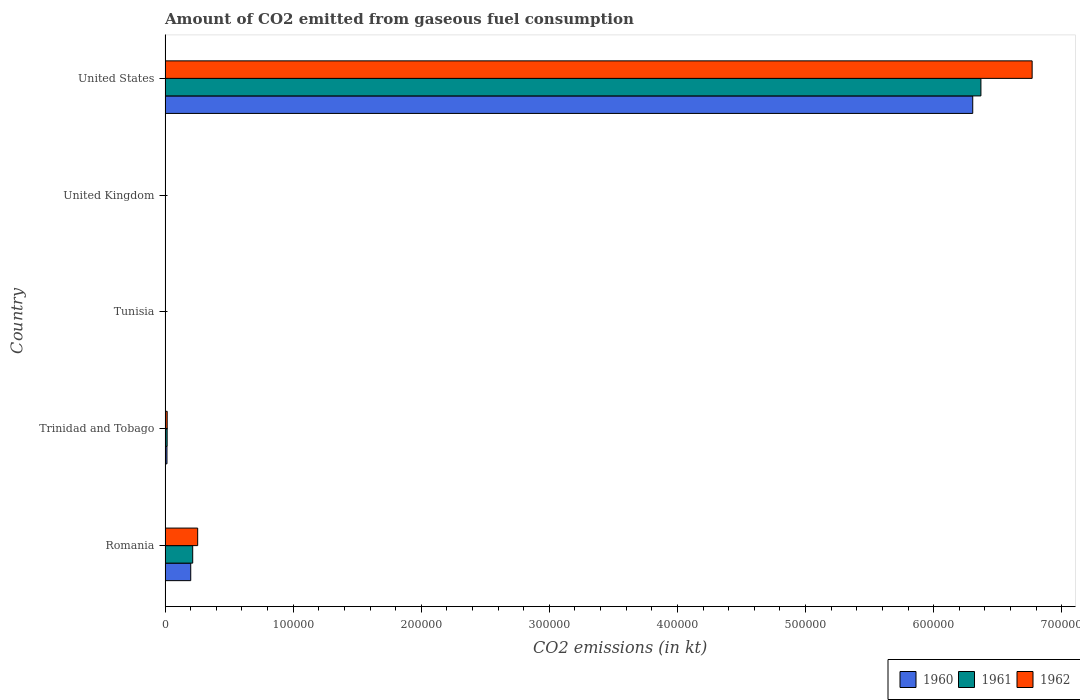How many different coloured bars are there?
Give a very brief answer. 3. Are the number of bars per tick equal to the number of legend labels?
Offer a very short reply. Yes. How many bars are there on the 5th tick from the top?
Your answer should be very brief. 3. What is the label of the 4th group of bars from the top?
Your answer should be very brief. Trinidad and Tobago. What is the amount of CO2 emitted in 1961 in Tunisia?
Make the answer very short. 14.67. Across all countries, what is the maximum amount of CO2 emitted in 1960?
Offer a very short reply. 6.31e+05. Across all countries, what is the minimum amount of CO2 emitted in 1962?
Offer a very short reply. 14.67. In which country was the amount of CO2 emitted in 1960 minimum?
Ensure brevity in your answer.  Tunisia. What is the total amount of CO2 emitted in 1961 in the graph?
Give a very brief answer. 6.60e+05. What is the difference between the amount of CO2 emitted in 1961 in Tunisia and that in United Kingdom?
Make the answer very short. -135.68. What is the difference between the amount of CO2 emitted in 1962 in Tunisia and the amount of CO2 emitted in 1961 in Trinidad and Tobago?
Provide a short and direct response. -1580.48. What is the average amount of CO2 emitted in 1962 per country?
Your response must be concise. 1.41e+05. What is the difference between the amount of CO2 emitted in 1961 and amount of CO2 emitted in 1962 in Trinidad and Tobago?
Offer a very short reply. -33. In how many countries, is the amount of CO2 emitted in 1962 greater than 140000 kt?
Your answer should be compact. 1. What is the ratio of the amount of CO2 emitted in 1960 in Romania to that in Tunisia?
Give a very brief answer. 1364.75. Is the amount of CO2 emitted in 1962 in Romania less than that in Tunisia?
Give a very brief answer. No. Is the difference between the amount of CO2 emitted in 1961 in Tunisia and United Kingdom greater than the difference between the amount of CO2 emitted in 1962 in Tunisia and United Kingdom?
Offer a terse response. Yes. What is the difference between the highest and the second highest amount of CO2 emitted in 1961?
Offer a terse response. 6.15e+05. What is the difference between the highest and the lowest amount of CO2 emitted in 1962?
Offer a terse response. 6.77e+05. Does the graph contain any zero values?
Give a very brief answer. No. Does the graph contain grids?
Make the answer very short. No. How many legend labels are there?
Keep it short and to the point. 3. How are the legend labels stacked?
Make the answer very short. Horizontal. What is the title of the graph?
Ensure brevity in your answer.  Amount of CO2 emitted from gaseous fuel consumption. What is the label or title of the X-axis?
Give a very brief answer. CO2 emissions (in kt). What is the CO2 emissions (in kt) of 1960 in Romania?
Offer a very short reply. 2.00e+04. What is the CO2 emissions (in kt) in 1961 in Romania?
Provide a succinct answer. 2.16e+04. What is the CO2 emissions (in kt) of 1962 in Romania?
Offer a terse response. 2.54e+04. What is the CO2 emissions (in kt) of 1960 in Trinidad and Tobago?
Your answer should be compact. 1466.8. What is the CO2 emissions (in kt) in 1961 in Trinidad and Tobago?
Provide a short and direct response. 1595.14. What is the CO2 emissions (in kt) in 1962 in Trinidad and Tobago?
Give a very brief answer. 1628.15. What is the CO2 emissions (in kt) of 1960 in Tunisia?
Make the answer very short. 14.67. What is the CO2 emissions (in kt) of 1961 in Tunisia?
Make the answer very short. 14.67. What is the CO2 emissions (in kt) of 1962 in Tunisia?
Make the answer very short. 14.67. What is the CO2 emissions (in kt) of 1960 in United Kingdom?
Keep it short and to the point. 150.35. What is the CO2 emissions (in kt) in 1961 in United Kingdom?
Offer a terse response. 150.35. What is the CO2 emissions (in kt) in 1962 in United Kingdom?
Offer a very short reply. 216.35. What is the CO2 emissions (in kt) in 1960 in United States?
Your answer should be very brief. 6.31e+05. What is the CO2 emissions (in kt) of 1961 in United States?
Keep it short and to the point. 6.37e+05. What is the CO2 emissions (in kt) in 1962 in United States?
Your answer should be very brief. 6.77e+05. Across all countries, what is the maximum CO2 emissions (in kt) in 1960?
Your answer should be compact. 6.31e+05. Across all countries, what is the maximum CO2 emissions (in kt) in 1961?
Your response must be concise. 6.37e+05. Across all countries, what is the maximum CO2 emissions (in kt) in 1962?
Offer a terse response. 6.77e+05. Across all countries, what is the minimum CO2 emissions (in kt) in 1960?
Offer a very short reply. 14.67. Across all countries, what is the minimum CO2 emissions (in kt) of 1961?
Provide a short and direct response. 14.67. Across all countries, what is the minimum CO2 emissions (in kt) in 1962?
Offer a very short reply. 14.67. What is the total CO2 emissions (in kt) in 1960 in the graph?
Keep it short and to the point. 6.52e+05. What is the total CO2 emissions (in kt) in 1961 in the graph?
Ensure brevity in your answer.  6.60e+05. What is the total CO2 emissions (in kt) of 1962 in the graph?
Provide a succinct answer. 7.04e+05. What is the difference between the CO2 emissions (in kt) of 1960 in Romania and that in Trinidad and Tobago?
Offer a very short reply. 1.86e+04. What is the difference between the CO2 emissions (in kt) of 1961 in Romania and that in Trinidad and Tobago?
Ensure brevity in your answer.  2.00e+04. What is the difference between the CO2 emissions (in kt) in 1962 in Romania and that in Trinidad and Tobago?
Provide a short and direct response. 2.38e+04. What is the difference between the CO2 emissions (in kt) in 1960 in Romania and that in Tunisia?
Provide a short and direct response. 2.00e+04. What is the difference between the CO2 emissions (in kt) of 1961 in Romania and that in Tunisia?
Give a very brief answer. 2.15e+04. What is the difference between the CO2 emissions (in kt) of 1962 in Romania and that in Tunisia?
Provide a succinct answer. 2.54e+04. What is the difference between the CO2 emissions (in kt) in 1960 in Romania and that in United Kingdom?
Offer a very short reply. 1.99e+04. What is the difference between the CO2 emissions (in kt) of 1961 in Romania and that in United Kingdom?
Provide a short and direct response. 2.14e+04. What is the difference between the CO2 emissions (in kt) of 1962 in Romania and that in United Kingdom?
Offer a very short reply. 2.52e+04. What is the difference between the CO2 emissions (in kt) in 1960 in Romania and that in United States?
Make the answer very short. -6.11e+05. What is the difference between the CO2 emissions (in kt) of 1961 in Romania and that in United States?
Your response must be concise. -6.15e+05. What is the difference between the CO2 emissions (in kt) in 1962 in Romania and that in United States?
Ensure brevity in your answer.  -6.51e+05. What is the difference between the CO2 emissions (in kt) in 1960 in Trinidad and Tobago and that in Tunisia?
Provide a succinct answer. 1452.13. What is the difference between the CO2 emissions (in kt) in 1961 in Trinidad and Tobago and that in Tunisia?
Provide a succinct answer. 1580.48. What is the difference between the CO2 emissions (in kt) of 1962 in Trinidad and Tobago and that in Tunisia?
Provide a short and direct response. 1613.48. What is the difference between the CO2 emissions (in kt) in 1960 in Trinidad and Tobago and that in United Kingdom?
Give a very brief answer. 1316.45. What is the difference between the CO2 emissions (in kt) in 1961 in Trinidad and Tobago and that in United Kingdom?
Offer a terse response. 1444.8. What is the difference between the CO2 emissions (in kt) in 1962 in Trinidad and Tobago and that in United Kingdom?
Your answer should be very brief. 1411.8. What is the difference between the CO2 emissions (in kt) of 1960 in Trinidad and Tobago and that in United States?
Ensure brevity in your answer.  -6.29e+05. What is the difference between the CO2 emissions (in kt) in 1961 in Trinidad and Tobago and that in United States?
Your answer should be very brief. -6.35e+05. What is the difference between the CO2 emissions (in kt) of 1962 in Trinidad and Tobago and that in United States?
Your answer should be compact. -6.75e+05. What is the difference between the CO2 emissions (in kt) of 1960 in Tunisia and that in United Kingdom?
Offer a terse response. -135.68. What is the difference between the CO2 emissions (in kt) in 1961 in Tunisia and that in United Kingdom?
Ensure brevity in your answer.  -135.68. What is the difference between the CO2 emissions (in kt) of 1962 in Tunisia and that in United Kingdom?
Make the answer very short. -201.69. What is the difference between the CO2 emissions (in kt) of 1960 in Tunisia and that in United States?
Your response must be concise. -6.31e+05. What is the difference between the CO2 emissions (in kt) in 1961 in Tunisia and that in United States?
Your answer should be compact. -6.37e+05. What is the difference between the CO2 emissions (in kt) of 1962 in Tunisia and that in United States?
Keep it short and to the point. -6.77e+05. What is the difference between the CO2 emissions (in kt) of 1960 in United Kingdom and that in United States?
Offer a very short reply. -6.30e+05. What is the difference between the CO2 emissions (in kt) of 1961 in United Kingdom and that in United States?
Offer a very short reply. -6.37e+05. What is the difference between the CO2 emissions (in kt) of 1962 in United Kingdom and that in United States?
Offer a very short reply. -6.77e+05. What is the difference between the CO2 emissions (in kt) in 1960 in Romania and the CO2 emissions (in kt) in 1961 in Trinidad and Tobago?
Offer a terse response. 1.84e+04. What is the difference between the CO2 emissions (in kt) in 1960 in Romania and the CO2 emissions (in kt) in 1962 in Trinidad and Tobago?
Offer a very short reply. 1.84e+04. What is the difference between the CO2 emissions (in kt) in 1961 in Romania and the CO2 emissions (in kt) in 1962 in Trinidad and Tobago?
Provide a short and direct response. 1.99e+04. What is the difference between the CO2 emissions (in kt) in 1960 in Romania and the CO2 emissions (in kt) in 1961 in Tunisia?
Keep it short and to the point. 2.00e+04. What is the difference between the CO2 emissions (in kt) in 1960 in Romania and the CO2 emissions (in kt) in 1962 in Tunisia?
Your answer should be very brief. 2.00e+04. What is the difference between the CO2 emissions (in kt) of 1961 in Romania and the CO2 emissions (in kt) of 1962 in Tunisia?
Offer a very short reply. 2.15e+04. What is the difference between the CO2 emissions (in kt) of 1960 in Romania and the CO2 emissions (in kt) of 1961 in United Kingdom?
Keep it short and to the point. 1.99e+04. What is the difference between the CO2 emissions (in kt) in 1960 in Romania and the CO2 emissions (in kt) in 1962 in United Kingdom?
Offer a very short reply. 1.98e+04. What is the difference between the CO2 emissions (in kt) of 1961 in Romania and the CO2 emissions (in kt) of 1962 in United Kingdom?
Your response must be concise. 2.13e+04. What is the difference between the CO2 emissions (in kt) in 1960 in Romania and the CO2 emissions (in kt) in 1961 in United States?
Keep it short and to the point. -6.17e+05. What is the difference between the CO2 emissions (in kt) of 1960 in Romania and the CO2 emissions (in kt) of 1962 in United States?
Provide a succinct answer. -6.57e+05. What is the difference between the CO2 emissions (in kt) in 1961 in Romania and the CO2 emissions (in kt) in 1962 in United States?
Your answer should be very brief. -6.55e+05. What is the difference between the CO2 emissions (in kt) in 1960 in Trinidad and Tobago and the CO2 emissions (in kt) in 1961 in Tunisia?
Provide a short and direct response. 1452.13. What is the difference between the CO2 emissions (in kt) in 1960 in Trinidad and Tobago and the CO2 emissions (in kt) in 1962 in Tunisia?
Your answer should be very brief. 1452.13. What is the difference between the CO2 emissions (in kt) in 1961 in Trinidad and Tobago and the CO2 emissions (in kt) in 1962 in Tunisia?
Offer a terse response. 1580.48. What is the difference between the CO2 emissions (in kt) in 1960 in Trinidad and Tobago and the CO2 emissions (in kt) in 1961 in United Kingdom?
Give a very brief answer. 1316.45. What is the difference between the CO2 emissions (in kt) of 1960 in Trinidad and Tobago and the CO2 emissions (in kt) of 1962 in United Kingdom?
Your response must be concise. 1250.45. What is the difference between the CO2 emissions (in kt) of 1961 in Trinidad and Tobago and the CO2 emissions (in kt) of 1962 in United Kingdom?
Give a very brief answer. 1378.79. What is the difference between the CO2 emissions (in kt) in 1960 in Trinidad and Tobago and the CO2 emissions (in kt) in 1961 in United States?
Ensure brevity in your answer.  -6.35e+05. What is the difference between the CO2 emissions (in kt) of 1960 in Trinidad and Tobago and the CO2 emissions (in kt) of 1962 in United States?
Offer a very short reply. -6.75e+05. What is the difference between the CO2 emissions (in kt) of 1961 in Trinidad and Tobago and the CO2 emissions (in kt) of 1962 in United States?
Provide a succinct answer. -6.75e+05. What is the difference between the CO2 emissions (in kt) in 1960 in Tunisia and the CO2 emissions (in kt) in 1961 in United Kingdom?
Keep it short and to the point. -135.68. What is the difference between the CO2 emissions (in kt) in 1960 in Tunisia and the CO2 emissions (in kt) in 1962 in United Kingdom?
Your answer should be compact. -201.69. What is the difference between the CO2 emissions (in kt) in 1961 in Tunisia and the CO2 emissions (in kt) in 1962 in United Kingdom?
Give a very brief answer. -201.69. What is the difference between the CO2 emissions (in kt) in 1960 in Tunisia and the CO2 emissions (in kt) in 1961 in United States?
Give a very brief answer. -6.37e+05. What is the difference between the CO2 emissions (in kt) in 1960 in Tunisia and the CO2 emissions (in kt) in 1962 in United States?
Ensure brevity in your answer.  -6.77e+05. What is the difference between the CO2 emissions (in kt) of 1961 in Tunisia and the CO2 emissions (in kt) of 1962 in United States?
Your response must be concise. -6.77e+05. What is the difference between the CO2 emissions (in kt) in 1960 in United Kingdom and the CO2 emissions (in kt) in 1961 in United States?
Ensure brevity in your answer.  -6.37e+05. What is the difference between the CO2 emissions (in kt) in 1960 in United Kingdom and the CO2 emissions (in kt) in 1962 in United States?
Your answer should be very brief. -6.77e+05. What is the difference between the CO2 emissions (in kt) of 1961 in United Kingdom and the CO2 emissions (in kt) of 1962 in United States?
Make the answer very short. -6.77e+05. What is the average CO2 emissions (in kt) of 1960 per country?
Give a very brief answer. 1.30e+05. What is the average CO2 emissions (in kt) of 1961 per country?
Provide a short and direct response. 1.32e+05. What is the average CO2 emissions (in kt) of 1962 per country?
Make the answer very short. 1.41e+05. What is the difference between the CO2 emissions (in kt) of 1960 and CO2 emissions (in kt) of 1961 in Romania?
Your response must be concise. -1536.47. What is the difference between the CO2 emissions (in kt) of 1960 and CO2 emissions (in kt) of 1962 in Romania?
Provide a short and direct response. -5408.82. What is the difference between the CO2 emissions (in kt) of 1961 and CO2 emissions (in kt) of 1962 in Romania?
Your answer should be compact. -3872.35. What is the difference between the CO2 emissions (in kt) of 1960 and CO2 emissions (in kt) of 1961 in Trinidad and Tobago?
Your response must be concise. -128.34. What is the difference between the CO2 emissions (in kt) in 1960 and CO2 emissions (in kt) in 1962 in Trinidad and Tobago?
Your response must be concise. -161.35. What is the difference between the CO2 emissions (in kt) of 1961 and CO2 emissions (in kt) of 1962 in Trinidad and Tobago?
Ensure brevity in your answer.  -33. What is the difference between the CO2 emissions (in kt) of 1960 and CO2 emissions (in kt) of 1962 in Tunisia?
Provide a succinct answer. 0. What is the difference between the CO2 emissions (in kt) of 1961 and CO2 emissions (in kt) of 1962 in Tunisia?
Your answer should be compact. 0. What is the difference between the CO2 emissions (in kt) of 1960 and CO2 emissions (in kt) of 1961 in United Kingdom?
Ensure brevity in your answer.  0. What is the difference between the CO2 emissions (in kt) in 1960 and CO2 emissions (in kt) in 1962 in United Kingdom?
Your answer should be very brief. -66.01. What is the difference between the CO2 emissions (in kt) in 1961 and CO2 emissions (in kt) in 1962 in United Kingdom?
Your answer should be compact. -66.01. What is the difference between the CO2 emissions (in kt) in 1960 and CO2 emissions (in kt) in 1961 in United States?
Offer a terse response. -6395.25. What is the difference between the CO2 emissions (in kt) of 1960 and CO2 emissions (in kt) of 1962 in United States?
Your answer should be compact. -4.64e+04. What is the difference between the CO2 emissions (in kt) in 1961 and CO2 emissions (in kt) in 1962 in United States?
Your answer should be very brief. -4.00e+04. What is the ratio of the CO2 emissions (in kt) of 1960 in Romania to that in Trinidad and Tobago?
Your answer should be compact. 13.65. What is the ratio of the CO2 emissions (in kt) of 1961 in Romania to that in Trinidad and Tobago?
Make the answer very short. 13.51. What is the ratio of the CO2 emissions (in kt) of 1962 in Romania to that in Trinidad and Tobago?
Provide a short and direct response. 15.62. What is the ratio of the CO2 emissions (in kt) in 1960 in Romania to that in Tunisia?
Make the answer very short. 1364.75. What is the ratio of the CO2 emissions (in kt) of 1961 in Romania to that in Tunisia?
Make the answer very short. 1469.5. What is the ratio of the CO2 emissions (in kt) of 1962 in Romania to that in Tunisia?
Make the answer very short. 1733.5. What is the ratio of the CO2 emissions (in kt) of 1960 in Romania to that in United Kingdom?
Your answer should be very brief. 133.15. What is the ratio of the CO2 emissions (in kt) of 1961 in Romania to that in United Kingdom?
Your answer should be compact. 143.37. What is the ratio of the CO2 emissions (in kt) of 1962 in Romania to that in United Kingdom?
Offer a terse response. 117.53. What is the ratio of the CO2 emissions (in kt) in 1960 in Romania to that in United States?
Your response must be concise. 0.03. What is the ratio of the CO2 emissions (in kt) in 1961 in Romania to that in United States?
Provide a succinct answer. 0.03. What is the ratio of the CO2 emissions (in kt) in 1962 in Romania to that in United States?
Offer a very short reply. 0.04. What is the ratio of the CO2 emissions (in kt) in 1960 in Trinidad and Tobago to that in Tunisia?
Ensure brevity in your answer.  100. What is the ratio of the CO2 emissions (in kt) in 1961 in Trinidad and Tobago to that in Tunisia?
Offer a very short reply. 108.75. What is the ratio of the CO2 emissions (in kt) in 1962 in Trinidad and Tobago to that in Tunisia?
Your answer should be compact. 111. What is the ratio of the CO2 emissions (in kt) of 1960 in Trinidad and Tobago to that in United Kingdom?
Your answer should be very brief. 9.76. What is the ratio of the CO2 emissions (in kt) in 1961 in Trinidad and Tobago to that in United Kingdom?
Keep it short and to the point. 10.61. What is the ratio of the CO2 emissions (in kt) of 1962 in Trinidad and Tobago to that in United Kingdom?
Ensure brevity in your answer.  7.53. What is the ratio of the CO2 emissions (in kt) in 1960 in Trinidad and Tobago to that in United States?
Keep it short and to the point. 0. What is the ratio of the CO2 emissions (in kt) of 1961 in Trinidad and Tobago to that in United States?
Make the answer very short. 0. What is the ratio of the CO2 emissions (in kt) in 1962 in Trinidad and Tobago to that in United States?
Offer a very short reply. 0. What is the ratio of the CO2 emissions (in kt) in 1960 in Tunisia to that in United Kingdom?
Offer a very short reply. 0.1. What is the ratio of the CO2 emissions (in kt) of 1961 in Tunisia to that in United Kingdom?
Give a very brief answer. 0.1. What is the ratio of the CO2 emissions (in kt) in 1962 in Tunisia to that in United Kingdom?
Make the answer very short. 0.07. What is the ratio of the CO2 emissions (in kt) of 1960 in Tunisia to that in United States?
Offer a very short reply. 0. What is the ratio of the CO2 emissions (in kt) in 1962 in Tunisia to that in United States?
Offer a very short reply. 0. What is the ratio of the CO2 emissions (in kt) of 1960 in United Kingdom to that in United States?
Ensure brevity in your answer.  0. What is the ratio of the CO2 emissions (in kt) in 1961 in United Kingdom to that in United States?
Your answer should be very brief. 0. What is the ratio of the CO2 emissions (in kt) in 1962 in United Kingdom to that in United States?
Offer a very short reply. 0. What is the difference between the highest and the second highest CO2 emissions (in kt) of 1960?
Keep it short and to the point. 6.11e+05. What is the difference between the highest and the second highest CO2 emissions (in kt) of 1961?
Give a very brief answer. 6.15e+05. What is the difference between the highest and the second highest CO2 emissions (in kt) in 1962?
Keep it short and to the point. 6.51e+05. What is the difference between the highest and the lowest CO2 emissions (in kt) of 1960?
Your response must be concise. 6.31e+05. What is the difference between the highest and the lowest CO2 emissions (in kt) of 1961?
Your response must be concise. 6.37e+05. What is the difference between the highest and the lowest CO2 emissions (in kt) in 1962?
Keep it short and to the point. 6.77e+05. 